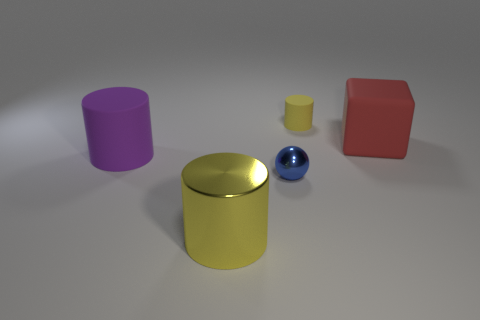There is a small object that is the same color as the large metal cylinder; what is its material?
Provide a short and direct response. Rubber. Do the tiny rubber cylinder and the cylinder in front of the purple thing have the same color?
Your response must be concise. Yes. Is there another thing that has the same color as the small rubber object?
Give a very brief answer. Yes. Are there the same number of blue shiny objects on the left side of the blue metallic ball and big shiny balls?
Provide a short and direct response. Yes. Is there a big purple cylinder in front of the big matte thing that is on the right side of the tiny yellow thing?
Your answer should be very brief. Yes. Is there any other thing that has the same color as the block?
Your answer should be very brief. No. Do the yellow cylinder behind the purple thing and the block have the same material?
Your answer should be very brief. Yes. Is the number of big yellow shiny cylinders behind the shiny ball the same as the number of big metallic cylinders right of the small matte cylinder?
Keep it short and to the point. Yes. What is the size of the rubber cylinder that is right of the rubber thing that is left of the tiny rubber object?
Make the answer very short. Small. What material is the thing that is both in front of the large purple cylinder and on the left side of the small sphere?
Ensure brevity in your answer.  Metal. 